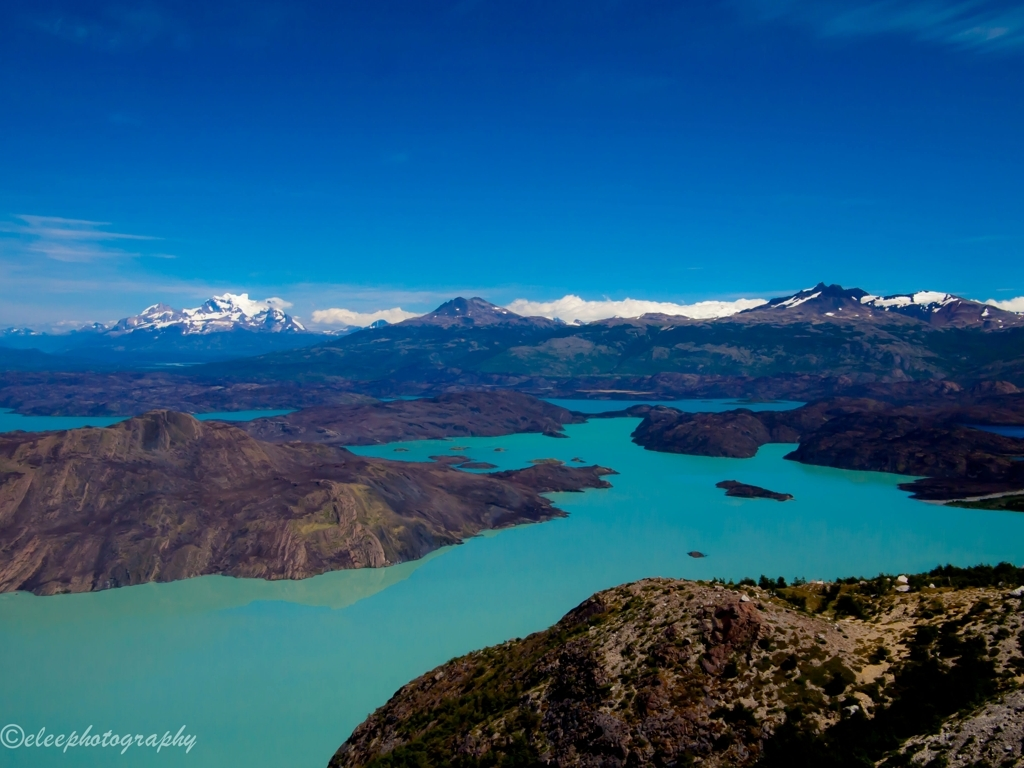What is the overall clarity of the image?
A. Poor
B. Blurry
C. Average
D. Excellent
Answer with the option's letter from the given choices directly.
 D. 